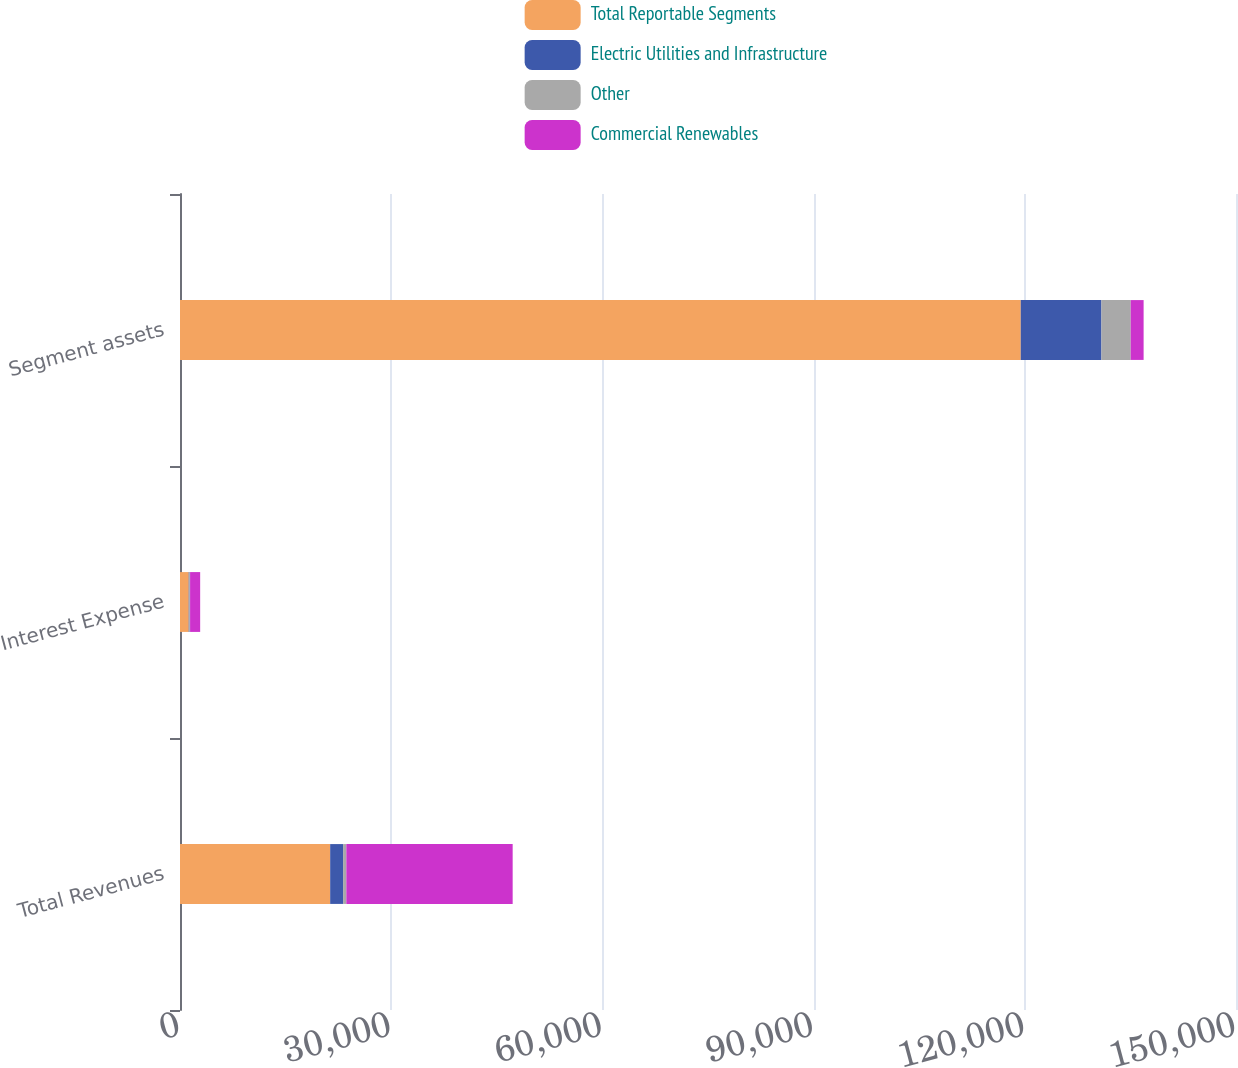Convert chart. <chart><loc_0><loc_0><loc_500><loc_500><stacked_bar_chart><ecel><fcel>Total Revenues<fcel>Interest Expense<fcel>Segment assets<nl><fcel>Total Reportable Segments<fcel>21331<fcel>1240<fcel>119423<nl><fcel>Electric Utilities and Infrastructure<fcel>1836<fcel>105<fcel>11462<nl><fcel>Other<fcel>460<fcel>87<fcel>4156<nl><fcel>Commercial Renewables<fcel>23627<fcel>1432<fcel>1836<nl></chart> 